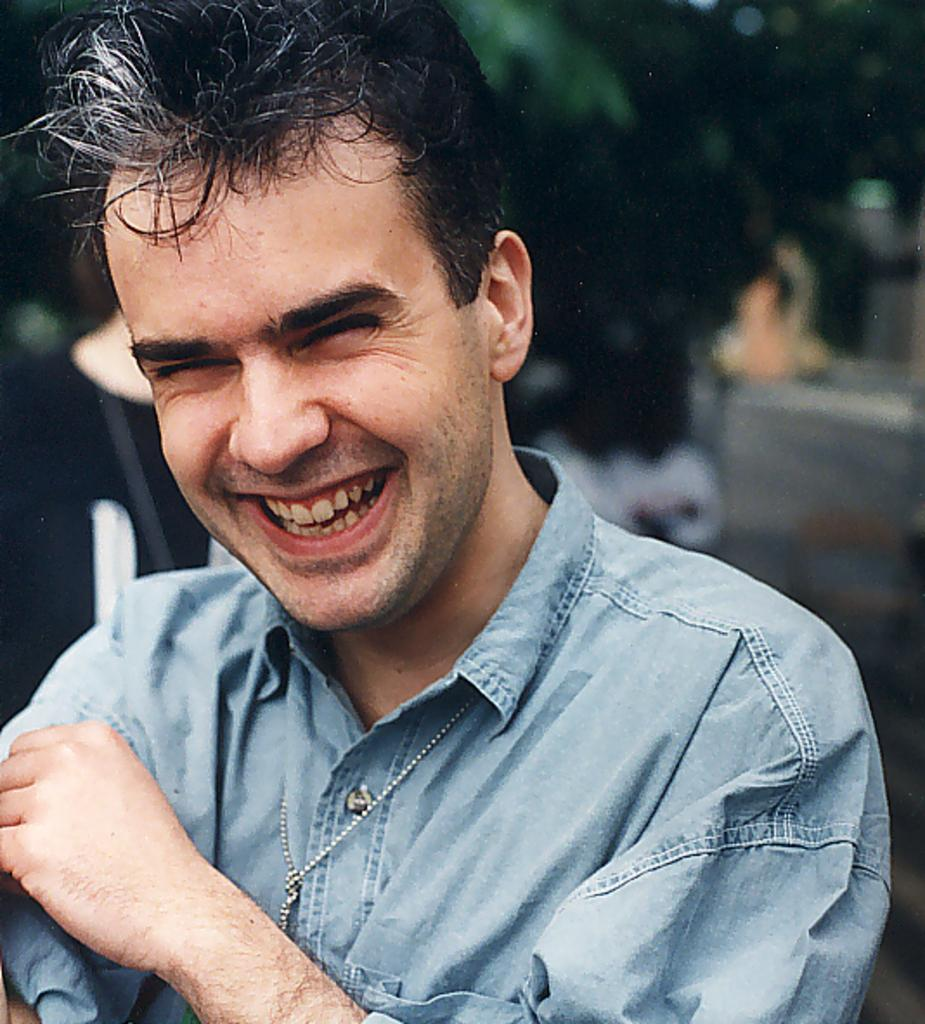What is present in the image? There is a person in the image. How is the person's expression? The person is smiling. Can you describe the background of the image? The background of the image is blurred. What type of lamp is the person playing in the image? There is no lamp or instrument present in the image; it only features a person smiling in a blurred background. 